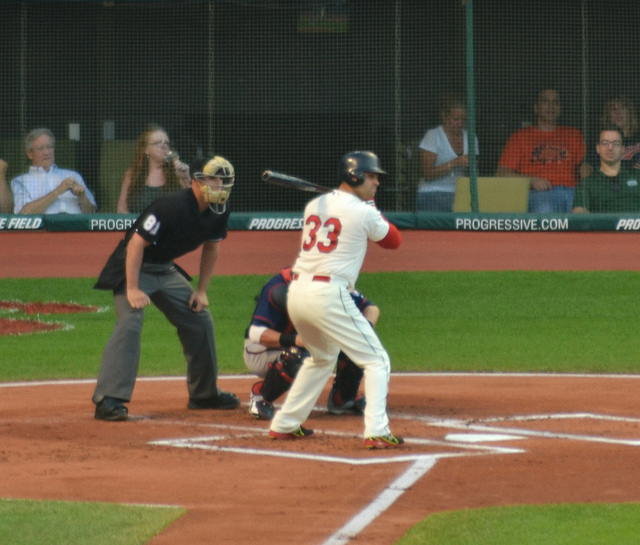<image>What is the current score of the game? I do not know the current score of the game. It could be any number combination such as '0 0', '1 0', '0 3', '1 2', '22 0', '1 1'. What is the logo on the shoes? I am not sure about the logo on the shoes. It can be seen as 'nike', 'swoosh' or 'adidas'. What is the logo on the shoes? I don't know what is the logo on the shoes. It can be seen 'nike', 'swoosh' or 'adidas'. What is the current score of the game? I don't know the current score of the game. It can be seen 'tie', '0 0', '1 0', '0 to 0', 'n', '0 3', '1 2', '22 0' or '1 1'. 